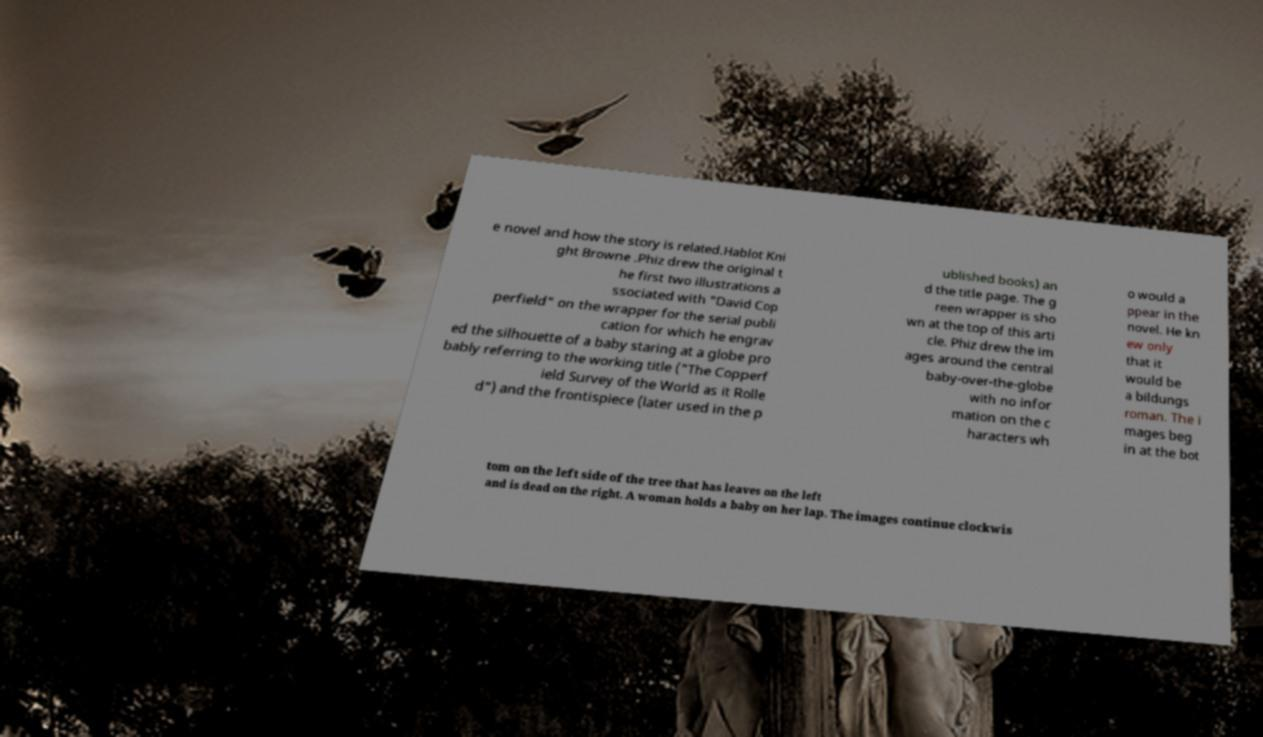There's text embedded in this image that I need extracted. Can you transcribe it verbatim? e novel and how the story is related.Hablot Kni ght Browne .Phiz drew the original t he first two illustrations a ssociated with "David Cop perfield" on the wrapper for the serial publi cation for which he engrav ed the silhouette of a baby staring at a globe pro bably referring to the working title ("The Copperf ield Survey of the World as it Rolle d") and the frontispiece (later used in the p ublished books) an d the title page. The g reen wrapper is sho wn at the top of this arti cle. Phiz drew the im ages around the central baby-over-the-globe with no infor mation on the c haracters wh o would a ppear in the novel. He kn ew only that it would be a bildungs roman. The i mages beg in at the bot tom on the left side of the tree that has leaves on the left and is dead on the right. A woman holds a baby on her lap. The images continue clockwis 